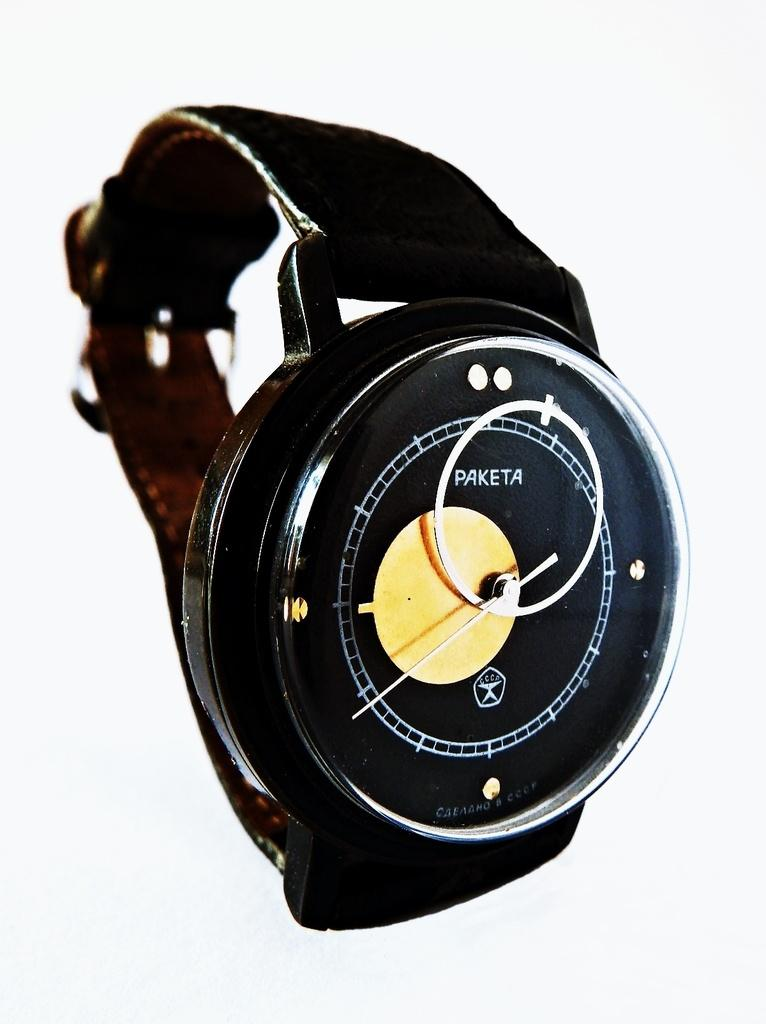<image>
Render a clear and concise summary of the photo. a Paketa wrist watch with a black face displayed on a white surface 